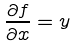<formula> <loc_0><loc_0><loc_500><loc_500>\frac { \partial f } { \partial x } = y</formula> 